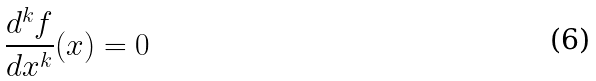<formula> <loc_0><loc_0><loc_500><loc_500>\frac { d ^ { k } f } { d x ^ { k } } ( x ) = 0</formula> 